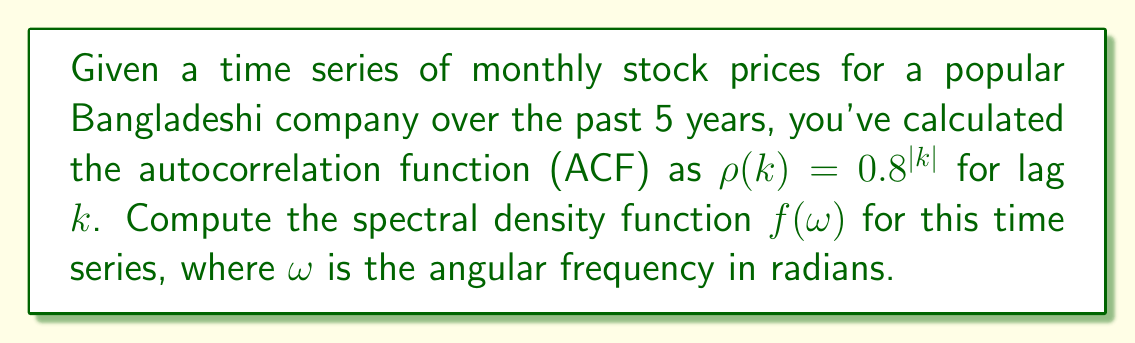Show me your answer to this math problem. To compute the spectral density function, we'll follow these steps:

1) The spectral density function is given by the Fourier transform of the autocorrelation function:

   $$f(\omega) = \frac{1}{2\pi} \sum_{k=-\infty}^{\infty} \rho(k) e^{-i\omega k}$$

2) In this case, $\rho(k) = 0.8^{|k|}$. We can split this sum into three parts:

   $$f(\omega) = \frac{1}{2\pi} \left(\sum_{k=-\infty}^{-1} 0.8^{|k|} e^{-i\omega k} + \rho(0) + \sum_{k=1}^{\infty} 0.8^{k} e^{-i\omega k}\right)$$

3) Simplify the first sum:

   $$\sum_{k=-\infty}^{-1} 0.8^{|k|} e^{-i\omega k} = \sum_{k=1}^{\infty} 0.8^k e^{i\omega k}$$

4) Now we have:

   $$f(\omega) = \frac{1}{2\pi} \left(\sum_{k=1}^{\infty} 0.8^k e^{i\omega k} + 1 + \sum_{k=1}^{\infty} 0.8^k e^{-i\omega k}\right)$$

5) Use the formula for the sum of a geometric series:

   $$\sum_{k=1}^{\infty} r^k = \frac{r}{1-r}$$ for $|r| < 1$

6) In our case, $r = 0.8e^{i\omega}$ and $r = 0.8e^{-i\omega}$ for the two sums respectively:

   $$f(\omega) = \frac{1}{2\pi} \left(\frac{0.8e^{i\omega}}{1-0.8e^{i\omega}} + 1 + \frac{0.8e^{-i\omega}}{1-0.8e^{-i\omega}}\right)$$

7) Find a common denominator:

   $$f(\omega) = \frac{1}{2\pi} \cdot \frac{0.8e^{i\omega}(1-0.8e^{-i\omega}) + (1-0.8e^{i\omega})(1-0.8e^{-i\omega}) + 0.8e^{-i\omega}(1-0.8e^{i\omega})}{(1-0.8e^{i\omega})(1-0.8e^{-i\omega})}$$

8) Simplify the numerator:

   $$f(\omega) = \frac{1}{2\pi} \cdot \frac{1-0.64}{1-1.6\cos(\omega)+0.64}$$

9) Final result:

   $$f(\omega) = \frac{0.36}{2\pi(1-1.6\cos(\omega)+0.64)}$$
Answer: $$f(\omega) = \frac{0.36}{2\pi(1-1.6\cos(\omega)+0.64)}$$ 